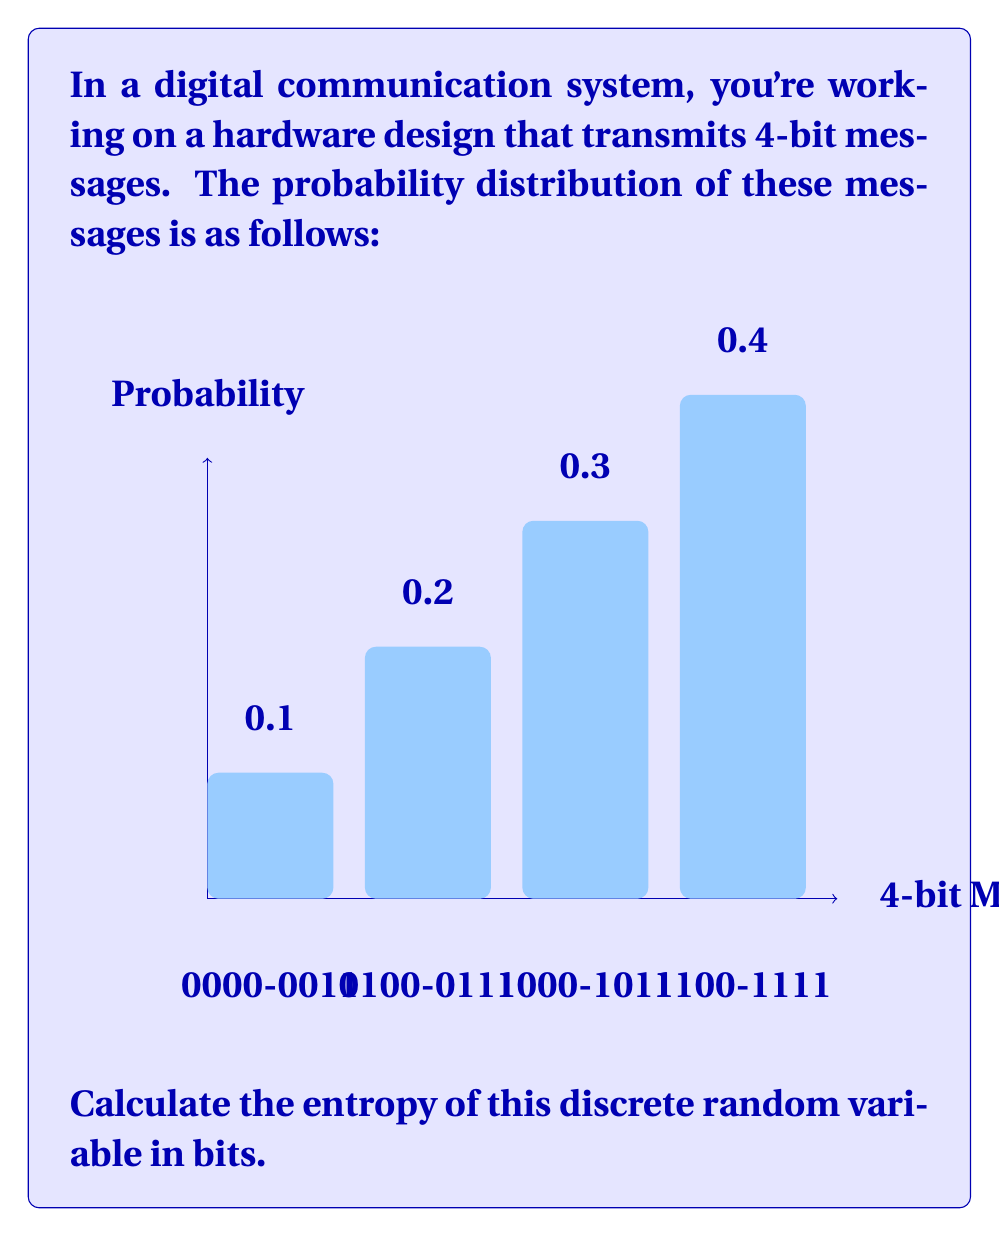Show me your answer to this math problem. To calculate the entropy of a discrete random variable, we use the formula:

$$H(X) = -\sum_{i=1}^{n} p(x_i) \log_2 p(x_i)$$

Where $p(x_i)$ is the probability of each outcome.

Given probabilities:
$p(x_1) = 0.1$ (for messages 0000-0011)
$p(x_2) = 0.2$ (for messages 0100-0111)
$p(x_3) = 0.3$ (for messages 1000-1011)
$p(x_4) = 0.4$ (for messages 1100-1111)

Let's calculate each term:

1) $-0.1 \log_2(0.1) = 0.1 \times 3.32 = 0.332$
2) $-0.2 \log_2(0.2) = 0.2 \times 2.32 = 0.464$
3) $-0.3 \log_2(0.3) = 0.3 \times 1.74 = 0.522$
4) $-0.4 \log_2(0.4) = 0.4 \times 1.32 = 0.528$

Now, sum all these terms:

$H(X) = 0.332 + 0.464 + 0.522 + 0.528 = 1.846$ bits

This value represents the average amount of information contained in each message transmission.
Answer: $1.846$ bits 